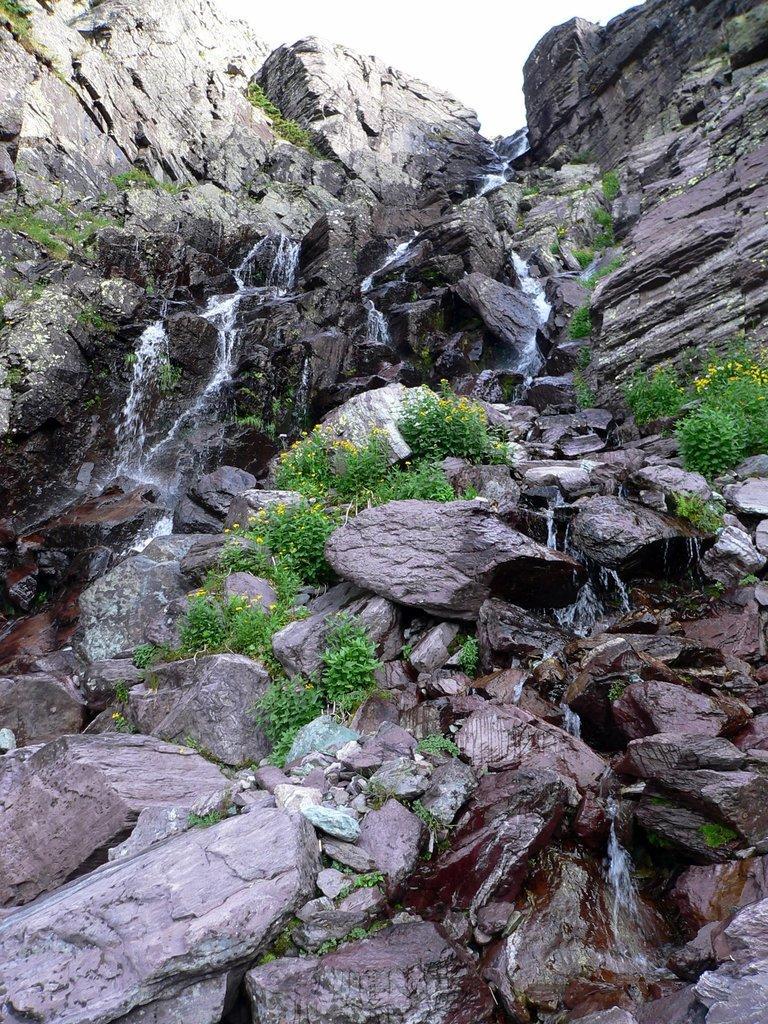Could you give a brief overview of what you see in this image? In this picture I can observe a hill. There is some water falling from the top of the hill. I can observe some plants in this picture. In the background there is sky. 